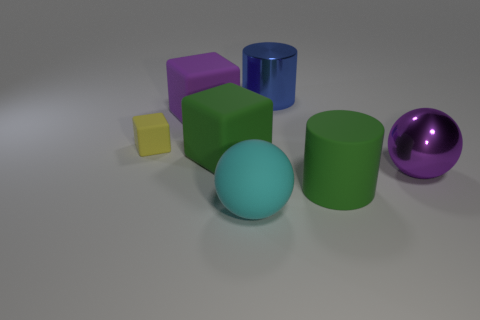Subtract all big purple blocks. How many blocks are left? 2 Add 1 purple balls. How many objects exist? 8 Subtract all cylinders. How many objects are left? 5 Add 6 large green blocks. How many large green blocks are left? 7 Add 5 gray rubber things. How many gray rubber things exist? 5 Subtract 0 brown spheres. How many objects are left? 7 Subtract all large cyan metallic spheres. Subtract all purple cubes. How many objects are left? 6 